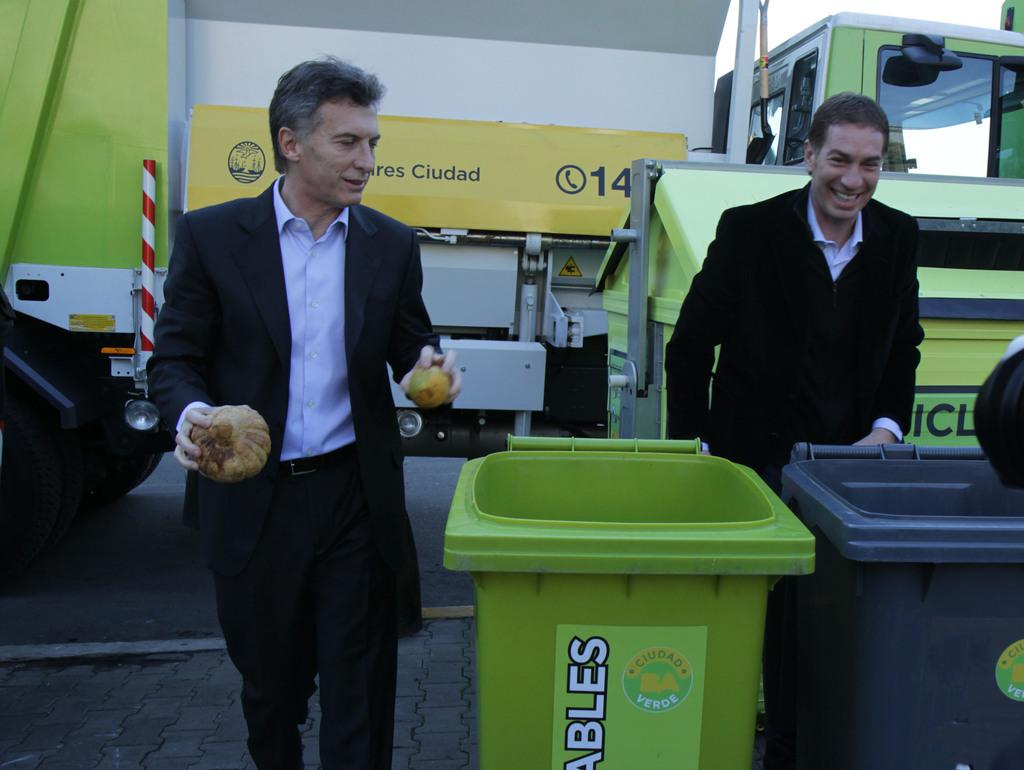<image>
Present a compact description of the photo's key features. Men standing in front of a yellow sign with the number 14. 